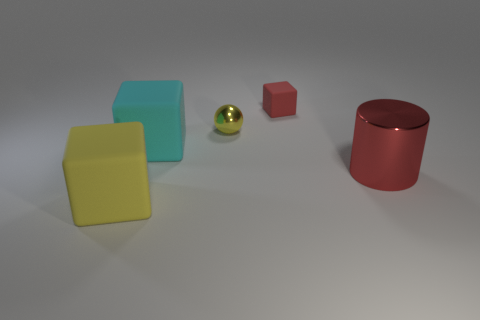Add 3 large brown cylinders. How many objects exist? 8 Subtract all cubes. How many objects are left? 2 Add 1 cyan matte objects. How many cyan matte objects exist? 2 Subtract 0 green cylinders. How many objects are left? 5 Subtract all tiny red metal blocks. Subtract all small red objects. How many objects are left? 4 Add 3 red shiny cylinders. How many red shiny cylinders are left? 4 